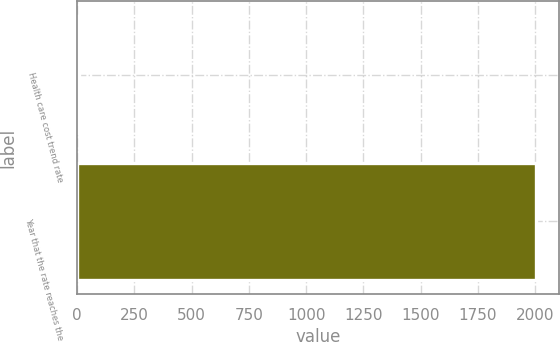<chart> <loc_0><loc_0><loc_500><loc_500><bar_chart><fcel>Health care cost trend rate<fcel>Year that the rate reaches the<nl><fcel>7<fcel>2004<nl></chart> 